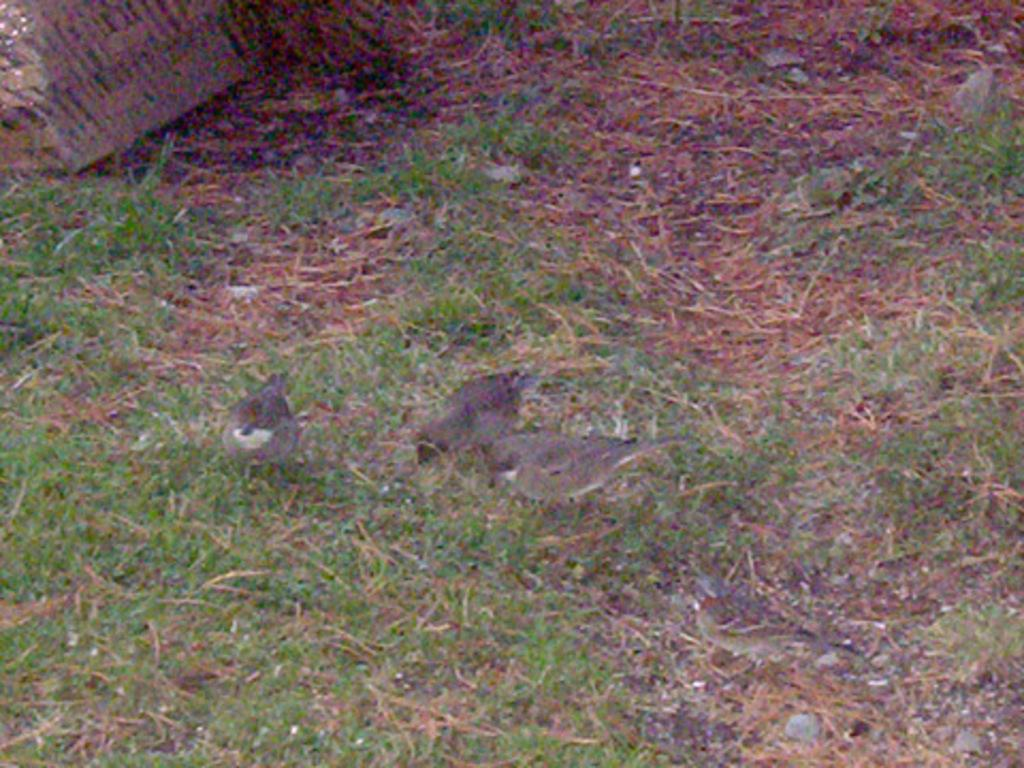What type of animals can be seen in the image? Birds can be seen in the image. What type of vegetation is present in the image? There is grass in the image, including dry grass. Can you describe the object located on the top left of the image? Unfortunately, the provided facts do not give any information about the object on the top left of the image. What type of butter is being spread on the grass in the image? There is no butter present in the image. What type of structure can be seen in the background of the image? The provided facts do not mention any structure in the background of the image. 